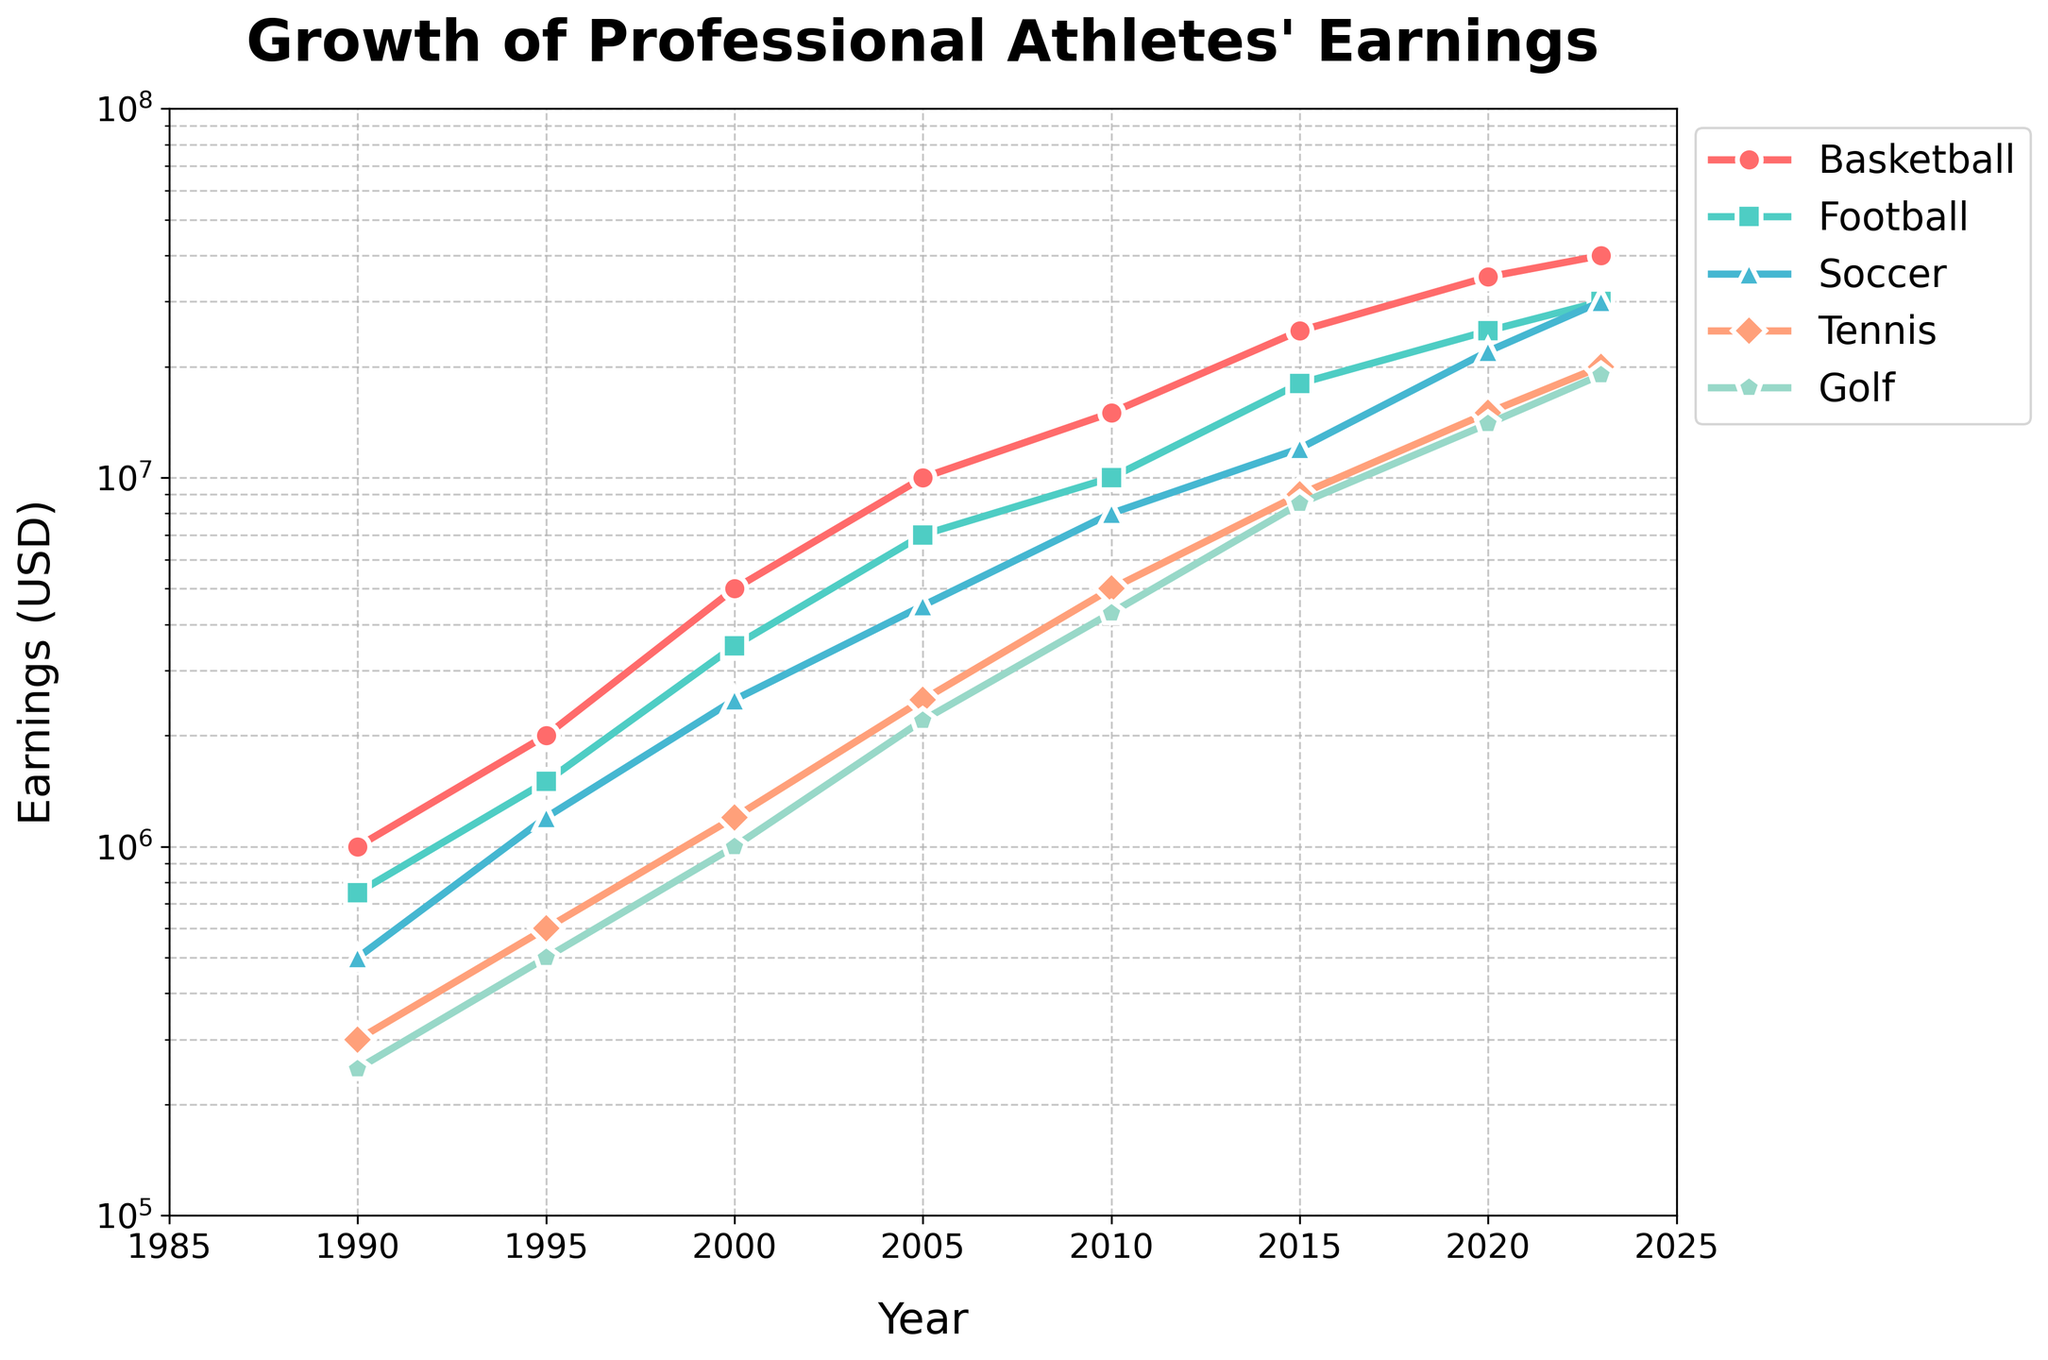What's the title of the figure? The title is displayed at the top of the figure, which states "Growth of Professional Athletes' Earnings".
Answer: Growth of Professional Athletes' Earnings Which sport shows the highest earnings in 2023? By looking at the rightmost data points in the figure for each sport, Basketball has the highest earnings in 2023.
Answer: Basketball How have the earnings in Soccer changed from 1990 to 2023? The data points for Soccer show an increase in earnings from $500,000 in 1990 to $30,000,000 in 2023. This is visible by comparing the first data point in 1990 and the last data point in 2023 on the Soccer line.
Answer: Increased from $500,000 to $30,000,000 Which two sports had similar earnings in 2023, and what were those earnings? Looking at the data points for 2023, both Soccer and Football show similar earnings, which appear around the $30,000,000 mark.
Answer: Soccer and Football, $30,000,000 What is the growth trend for Tennis earnings observed in the plot? The earnings for Tennis show an upward trend with a gradual increase from 1990 to 2023. This can be seen from the plot where the points continuously rise year by year.
Answer: Upward trend Between 1995 and 2000, which sport showed the highest percentage increase in earnings? Comparing the 1995 and 2000 earnings for each sport:
- Basketball: $2,000,000 to $5,000,000 (150% increase)
- Football: $1,500,000 to $3,500,000 (133% increase)
- Soccer: $1,200,000 to $2,500,000 (108% increase)
- Tennis: $600,000 to $1,200,000 (100% increase)
- Golf: $500,000 to $1,000,000 (100% increase)
Basketball shows the highest percentage increase at 150%.
Answer: Basketball How does the growth rate of earnings in Golf compare to that in Basketball? By observing the slopes of the lines representing Golf and Basketball: 
- Basketball shows a steeper slope, indicating a faster growth rate.
- Golf's slope is less steep, suggesting a slower growth rate.
Thus, Basketball has a higher growth rate.
Answer: Basketball has a higher growth rate What are the approximate earnings for Football in 2010, and how does it compare to Tennis in the same year? From the plot, Football earnings in 2010 are around $10,000,000, and Tennis earnings in 2010 are around $5,000,000. Football earnings in 2010 are approximately twice that of Tennis.
Answer: Football: $10,000,000, Tennis: $5,000,000 What's the median value of Tennis earnings data points shown in the plot? The data points for Tennis earnings are: $300,000, $600,000, $1,200,000, $2,500,000, $5,000,000, $9,000,000, $15,000,000, $20,000,000. The median is the middle value when sorted: $3,500,000 (between $2,500,000 and $5,000,000).
Answer: $3,500,000 How do the earnings distributions of Football and Basketball compare across the years? Both distributions show an upward trend, with Basketball having consistently higher earnings. The gap between them remains, Basketball's slope is steeper, indicating a higher rate of increase.
Answer: Basketball consistently higher, steeper increase 